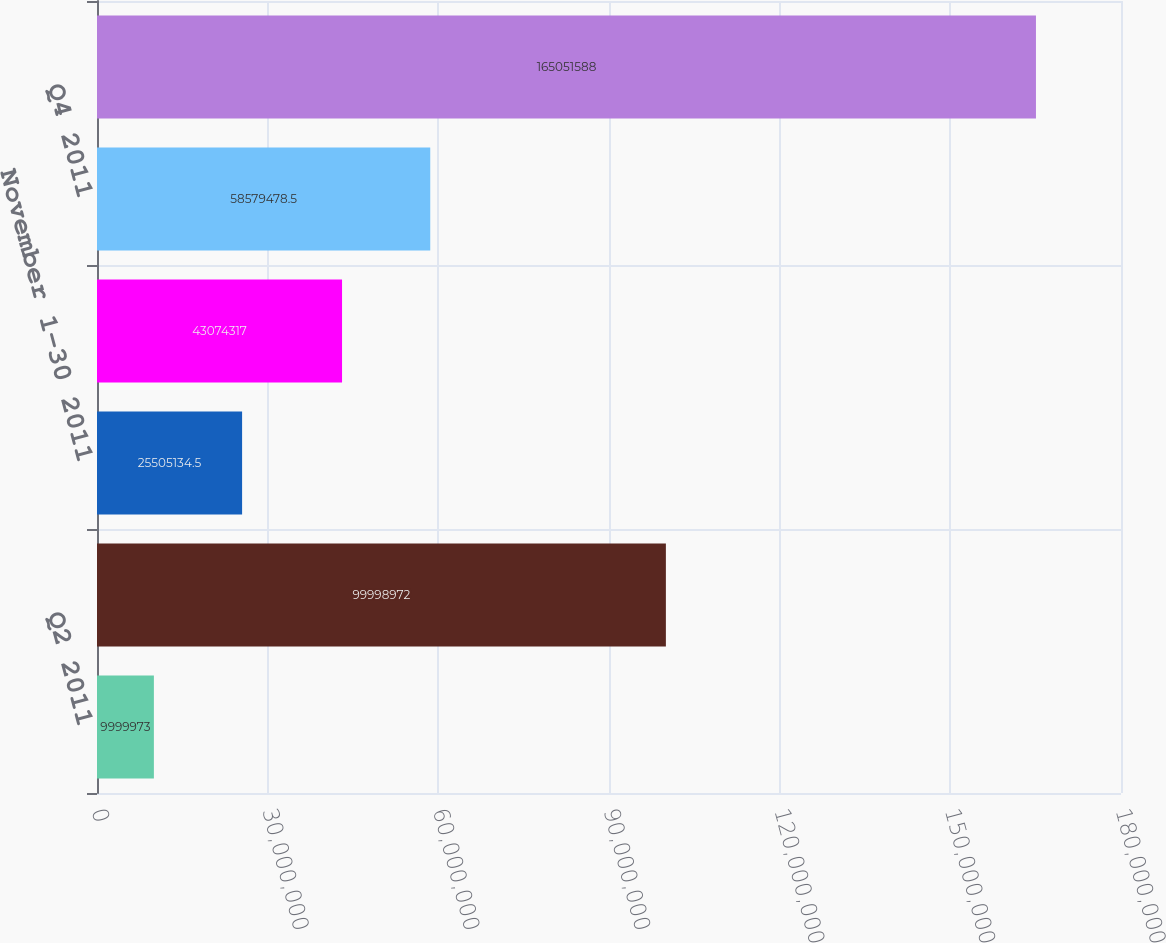Convert chart. <chart><loc_0><loc_0><loc_500><loc_500><bar_chart><fcel>Q2 2011<fcel>Q3 2011<fcel>November 1-30 2011<fcel>December 1-31 2011<fcel>Q4 2011<fcel>TOTAL 2011<nl><fcel>9.99997e+06<fcel>9.9999e+07<fcel>2.55051e+07<fcel>4.30743e+07<fcel>5.85795e+07<fcel>1.65052e+08<nl></chart> 